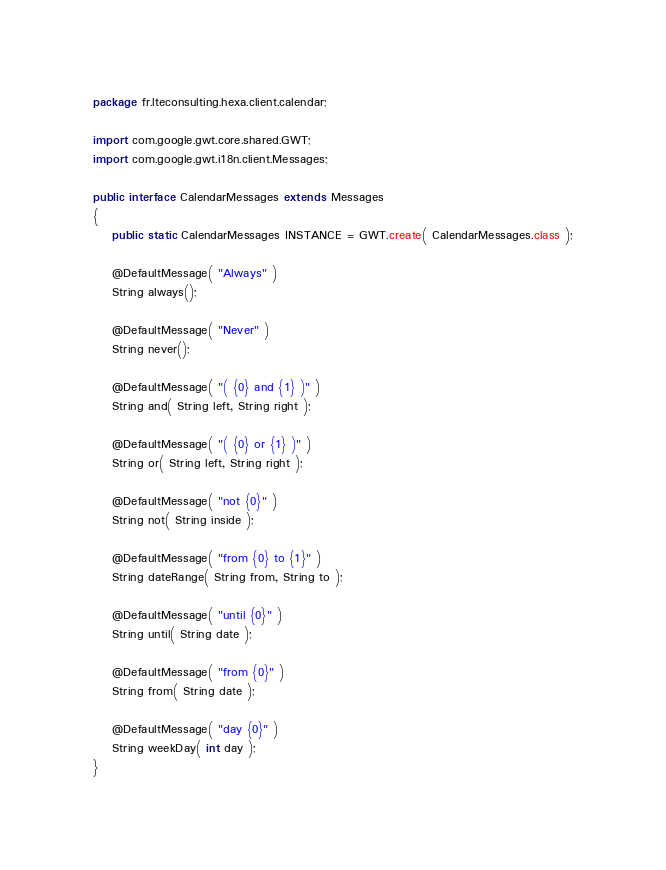Convert code to text. <code><loc_0><loc_0><loc_500><loc_500><_Java_>package fr.lteconsulting.hexa.client.calendar;

import com.google.gwt.core.shared.GWT;
import com.google.gwt.i18n.client.Messages;

public interface CalendarMessages extends Messages
{
	public static CalendarMessages INSTANCE = GWT.create( CalendarMessages.class );

	@DefaultMessage( "Always" )
	String always();

	@DefaultMessage( "Never" )
	String never();

	@DefaultMessage( "( {0} and {1} )" )
	String and( String left, String right );

	@DefaultMessage( "( {0} or {1} )" )
	String or( String left, String right );

	@DefaultMessage( "not {0}" )
	String not( String inside );

	@DefaultMessage( "from {0} to {1}" )
	String dateRange( String from, String to );

	@DefaultMessage( "until {0}" )
	String until( String date );

	@DefaultMessage( "from {0}" )
	String from( String date );

	@DefaultMessage( "day {0}" )
	String weekDay( int day );
}
</code> 